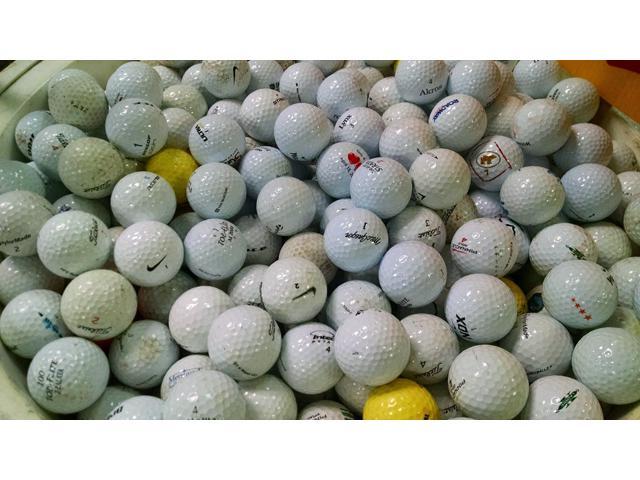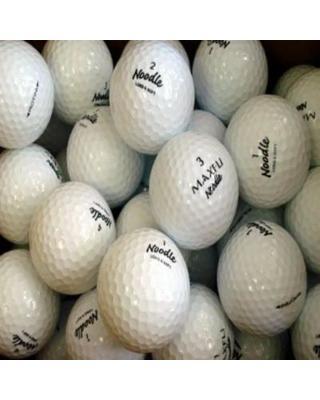The first image is the image on the left, the second image is the image on the right. Assess this claim about the two images: "In at least in image there are at least thirty dirty and muddy golf balls.". Correct or not? Answer yes or no. Yes. The first image is the image on the left, the second image is the image on the right. Examine the images to the left and right. Is the description "One of the images contains nothing but golf balls, the other shows a brown that contains them." accurate? Answer yes or no. No. 